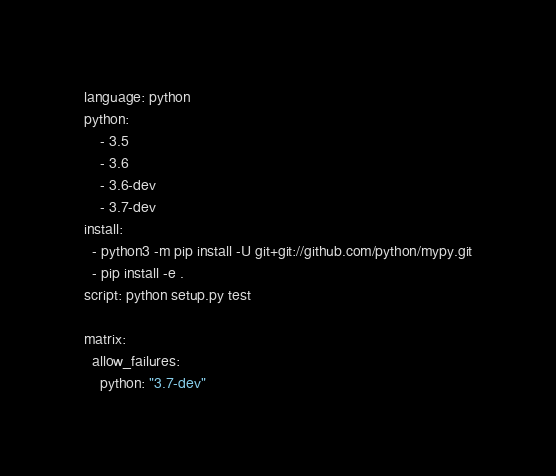Convert code to text. <code><loc_0><loc_0><loc_500><loc_500><_YAML_>language: python
python:
    - 3.5
    - 3.6
    - 3.6-dev
    - 3.7-dev
install:
  - python3 -m pip install -U git+git://github.com/python/mypy.git
  - pip install -e .
script: python setup.py test

matrix:
  allow_failures:
    python: "3.7-dev"
</code> 